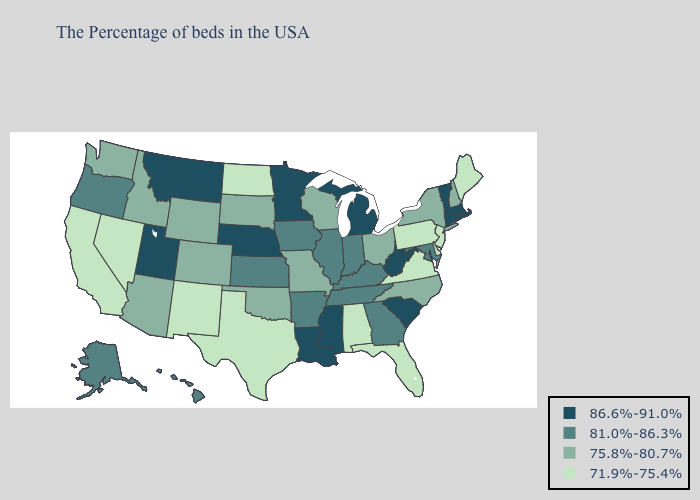What is the value of Mississippi?
Be succinct. 86.6%-91.0%. What is the highest value in the USA?
Answer briefly. 86.6%-91.0%. Name the states that have a value in the range 86.6%-91.0%?
Give a very brief answer. Massachusetts, Rhode Island, Vermont, Connecticut, South Carolina, West Virginia, Michigan, Mississippi, Louisiana, Minnesota, Nebraska, Utah, Montana. Does Wyoming have a higher value than Alaska?
Write a very short answer. No. What is the value of Louisiana?
Write a very short answer. 86.6%-91.0%. Does Minnesota have the highest value in the USA?
Answer briefly. Yes. What is the value of Idaho?
Answer briefly. 75.8%-80.7%. Name the states that have a value in the range 71.9%-75.4%?
Answer briefly. Maine, New Jersey, Delaware, Pennsylvania, Virginia, Florida, Alabama, Texas, North Dakota, New Mexico, Nevada, California. Which states hav the highest value in the Northeast?
Short answer required. Massachusetts, Rhode Island, Vermont, Connecticut. Which states hav the highest value in the MidWest?
Be succinct. Michigan, Minnesota, Nebraska. Does the map have missing data?
Concise answer only. No. Does Montana have the highest value in the USA?
Keep it brief. Yes. What is the value of North Carolina?
Short answer required. 75.8%-80.7%. What is the lowest value in states that border Texas?
Answer briefly. 71.9%-75.4%. What is the lowest value in states that border South Carolina?
Give a very brief answer. 75.8%-80.7%. 